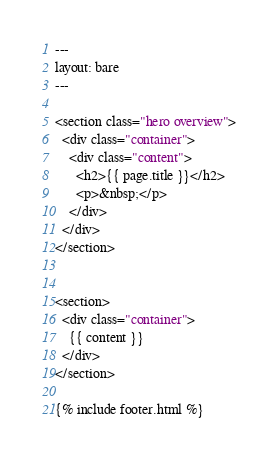Convert code to text. <code><loc_0><loc_0><loc_500><loc_500><_HTML_>---
layout: bare
---

<section class="hero overview">
  <div class="container">
    <div class="content">
      <h2>{{ page.title }}</h2>
      <p>&nbsp;</p>
    </div>
  </div>
</section>


<section>
  <div class="container">
    {{ content }}
  </div>
</section>

{% include footer.html %}
</code> 